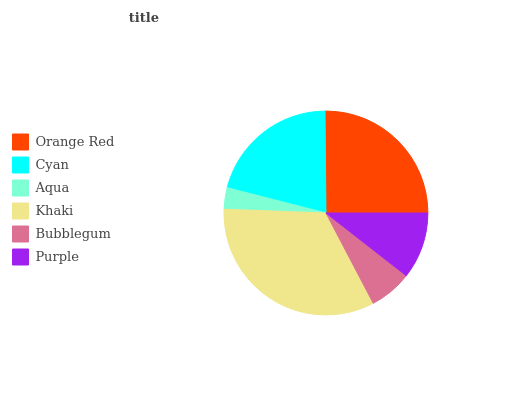Is Aqua the minimum?
Answer yes or no. Yes. Is Khaki the maximum?
Answer yes or no. Yes. Is Cyan the minimum?
Answer yes or no. No. Is Cyan the maximum?
Answer yes or no. No. Is Orange Red greater than Cyan?
Answer yes or no. Yes. Is Cyan less than Orange Red?
Answer yes or no. Yes. Is Cyan greater than Orange Red?
Answer yes or no. No. Is Orange Red less than Cyan?
Answer yes or no. No. Is Cyan the high median?
Answer yes or no. Yes. Is Purple the low median?
Answer yes or no. Yes. Is Aqua the high median?
Answer yes or no. No. Is Khaki the low median?
Answer yes or no. No. 